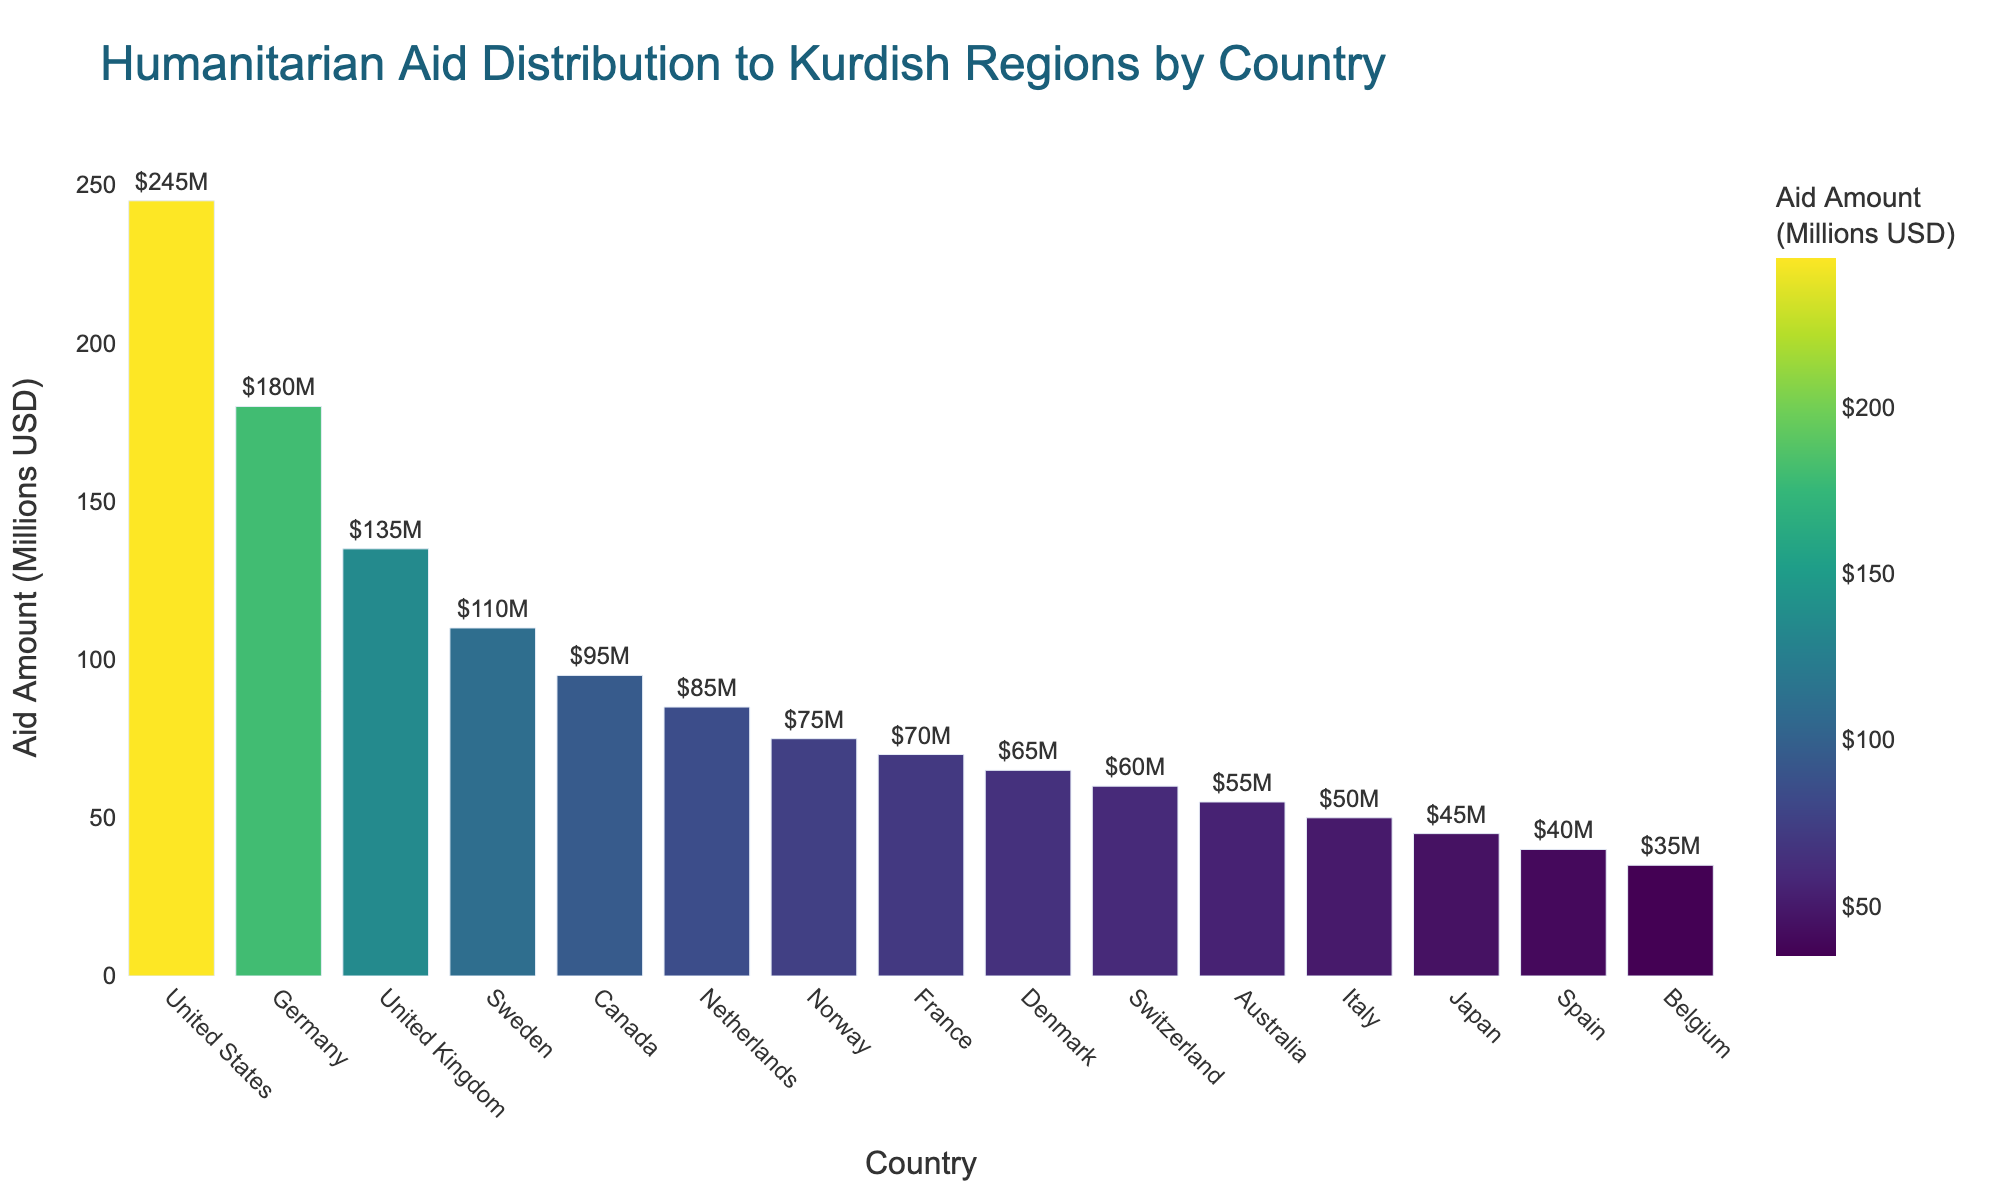what is the total amount of humanitarian aid provided by the top three countries? Sum the aid amounts of the top three countries, which are the United States (245 million USD), Germany (180 million USD), and the United Kingdom (135 million USD). The total is 245 + 180 + 135 = 560 million USD
Answer: 560 million USD Which country provides the least amount of humanitarian aid to Kurdish regions, and how much do they provide? Identify the country with the smallest value on the bar chart. Belgium provides the least amount with 35 million USD
Answer: Belgium, 35 million USD How does the aid provided by Canada compare to that provided by Norway? Look at the heights of the bars for Canada and Norway. Canada's aid amount is 95 million USD, and Norway's is 75 million USD. Therefore, Canada provides more aid than Norway by 20 million USD
Answer: Canada provides 20 million USD more Is there a larger difference in aid amounts between Germany and the United Kingdom or between Sweden and Norway? Calculate the differences: Germany and the United Kingdom is 180 - 135 = 45 million USD; Sweden and Norway is 110 - 75 = 35 million USD. The difference between Germany and the United Kingdom is larger
Answer: Germany and the United Kingdom, 45 million USD What is the average amount of humanitarian aid provided by the European countries in the list? Summing contributions of European countries: Germany (180), United Kingdom (135), Sweden (110), Netherlands (85), Norway (75), France (70), Denmark (65), Switzerland (60), Italy (50), Spain (40), Belgium (35), totals 905 million USD. Dividing by the 11 European countries, 905/11 ≈ 82.27
Answer: Approximately 82.27 million USD Compare the aid contributions of the United States and Japan. What can you infer from their contributions? The United States provides 245 million USD, while Japan provides 45 million USD. The US contributes significantly more than Japan, with a difference of 200 million USD
Answer: The US contributes 200 million USD more What is the median aid amount provided by the listed countries? Sort the aid amounts in ascending order and find the middle value: 35, 40, 45, 50, 55, 60, 65, 70, 75, 85, 95, 110, 135, 180, 245. The median is the 8th value, which is 70 million USD
Answer: 70 million USD Which country has an aid amount closest to the average aid amount provided by all countries? Calculate the average aid amount: Total sum (1295 million USD) divided by the number of countries (15) is 86.33 million USD. The closest amount is the Netherlands with 85 million USD
Answer: Netherlands, 85 million USD 